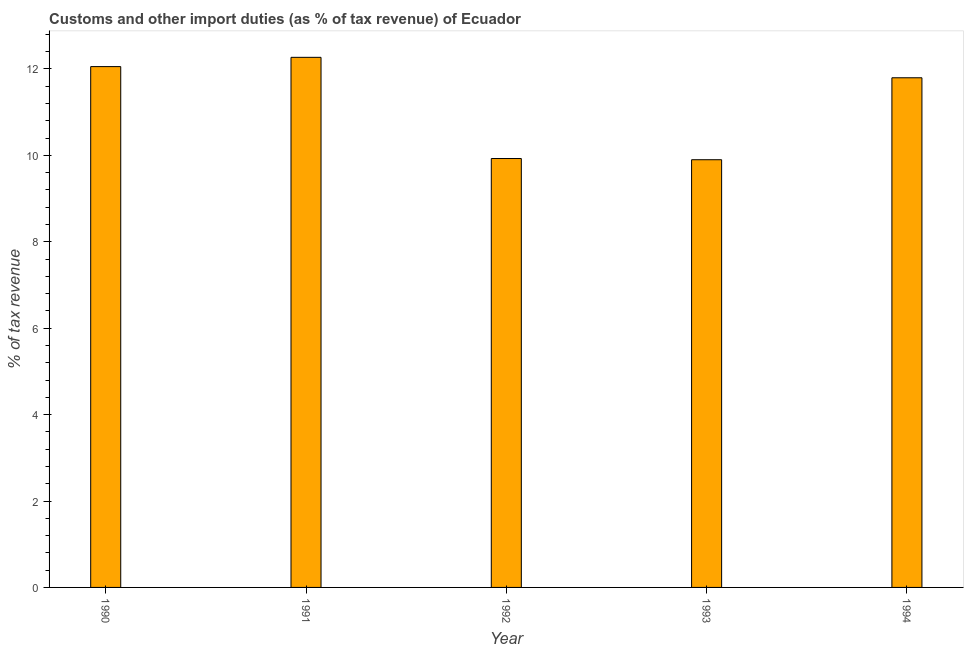Does the graph contain grids?
Make the answer very short. No. What is the title of the graph?
Offer a terse response. Customs and other import duties (as % of tax revenue) of Ecuador. What is the label or title of the Y-axis?
Provide a short and direct response. % of tax revenue. What is the customs and other import duties in 1992?
Provide a short and direct response. 9.93. Across all years, what is the maximum customs and other import duties?
Provide a short and direct response. 12.27. Across all years, what is the minimum customs and other import duties?
Ensure brevity in your answer.  9.9. In which year was the customs and other import duties minimum?
Your response must be concise. 1993. What is the sum of the customs and other import duties?
Provide a short and direct response. 55.95. What is the difference between the customs and other import duties in 1991 and 1994?
Offer a terse response. 0.47. What is the average customs and other import duties per year?
Your response must be concise. 11.19. What is the median customs and other import duties?
Offer a terse response. 11.8. Do a majority of the years between 1990 and 1992 (inclusive) have customs and other import duties greater than 4.4 %?
Keep it short and to the point. Yes. What is the ratio of the customs and other import duties in 1991 to that in 1993?
Make the answer very short. 1.24. Is the difference between the customs and other import duties in 1990 and 1993 greater than the difference between any two years?
Make the answer very short. No. What is the difference between the highest and the second highest customs and other import duties?
Your answer should be very brief. 0.21. What is the difference between the highest and the lowest customs and other import duties?
Ensure brevity in your answer.  2.37. Are all the bars in the graph horizontal?
Your answer should be very brief. No. How many years are there in the graph?
Offer a terse response. 5. What is the difference between two consecutive major ticks on the Y-axis?
Your answer should be very brief. 2. Are the values on the major ticks of Y-axis written in scientific E-notation?
Offer a very short reply. No. What is the % of tax revenue of 1990?
Your answer should be very brief. 12.05. What is the % of tax revenue in 1991?
Ensure brevity in your answer.  12.27. What is the % of tax revenue in 1992?
Ensure brevity in your answer.  9.93. What is the % of tax revenue of 1993?
Make the answer very short. 9.9. What is the % of tax revenue in 1994?
Your response must be concise. 11.8. What is the difference between the % of tax revenue in 1990 and 1991?
Your answer should be compact. -0.21. What is the difference between the % of tax revenue in 1990 and 1992?
Your response must be concise. 2.13. What is the difference between the % of tax revenue in 1990 and 1993?
Ensure brevity in your answer.  2.16. What is the difference between the % of tax revenue in 1990 and 1994?
Your response must be concise. 0.26. What is the difference between the % of tax revenue in 1991 and 1992?
Keep it short and to the point. 2.34. What is the difference between the % of tax revenue in 1991 and 1993?
Keep it short and to the point. 2.37. What is the difference between the % of tax revenue in 1991 and 1994?
Keep it short and to the point. 0.47. What is the difference between the % of tax revenue in 1992 and 1993?
Your answer should be compact. 0.03. What is the difference between the % of tax revenue in 1992 and 1994?
Your answer should be very brief. -1.87. What is the difference between the % of tax revenue in 1993 and 1994?
Keep it short and to the point. -1.9. What is the ratio of the % of tax revenue in 1990 to that in 1991?
Ensure brevity in your answer.  0.98. What is the ratio of the % of tax revenue in 1990 to that in 1992?
Provide a short and direct response. 1.21. What is the ratio of the % of tax revenue in 1990 to that in 1993?
Provide a short and direct response. 1.22. What is the ratio of the % of tax revenue in 1990 to that in 1994?
Your answer should be very brief. 1.02. What is the ratio of the % of tax revenue in 1991 to that in 1992?
Provide a short and direct response. 1.24. What is the ratio of the % of tax revenue in 1991 to that in 1993?
Ensure brevity in your answer.  1.24. What is the ratio of the % of tax revenue in 1992 to that in 1994?
Offer a very short reply. 0.84. What is the ratio of the % of tax revenue in 1993 to that in 1994?
Keep it short and to the point. 0.84. 